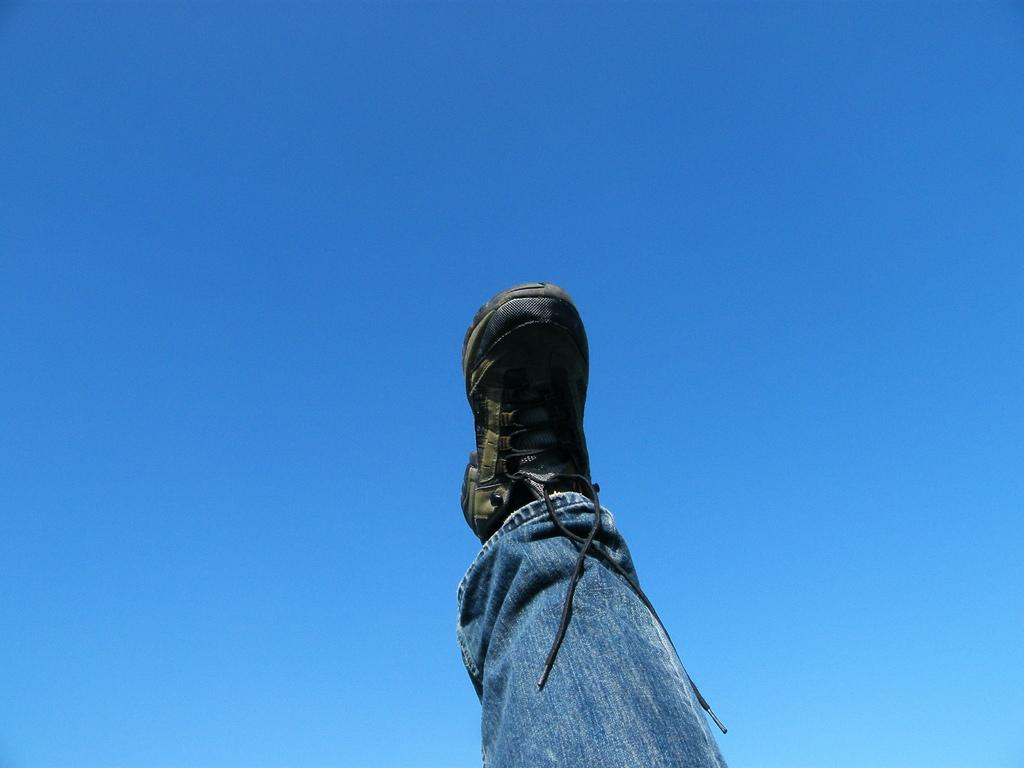What part of a person can be seen in the image? There is a leg of a person visible in the image. What is visible at the top of the image? The sky is visible at the top of the image. What is the color of the sky in the image? The color of the sky is blue. Can you see any dimes in the image? There are no dimes visible in the image. Is the person in the image stuck in quicksand? There is no indication of quicksand in the image, and only a leg of a person is visible. 